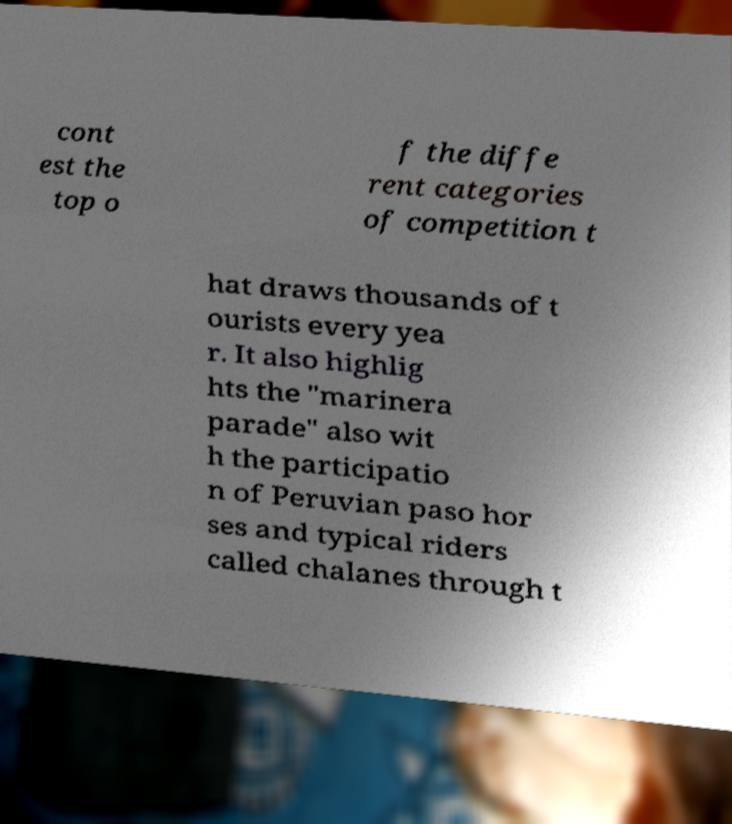I need the written content from this picture converted into text. Can you do that? cont est the top o f the diffe rent categories of competition t hat draws thousands of t ourists every yea r. It also highlig hts the "marinera parade" also wit h the participatio n of Peruvian paso hor ses and typical riders called chalanes through t 